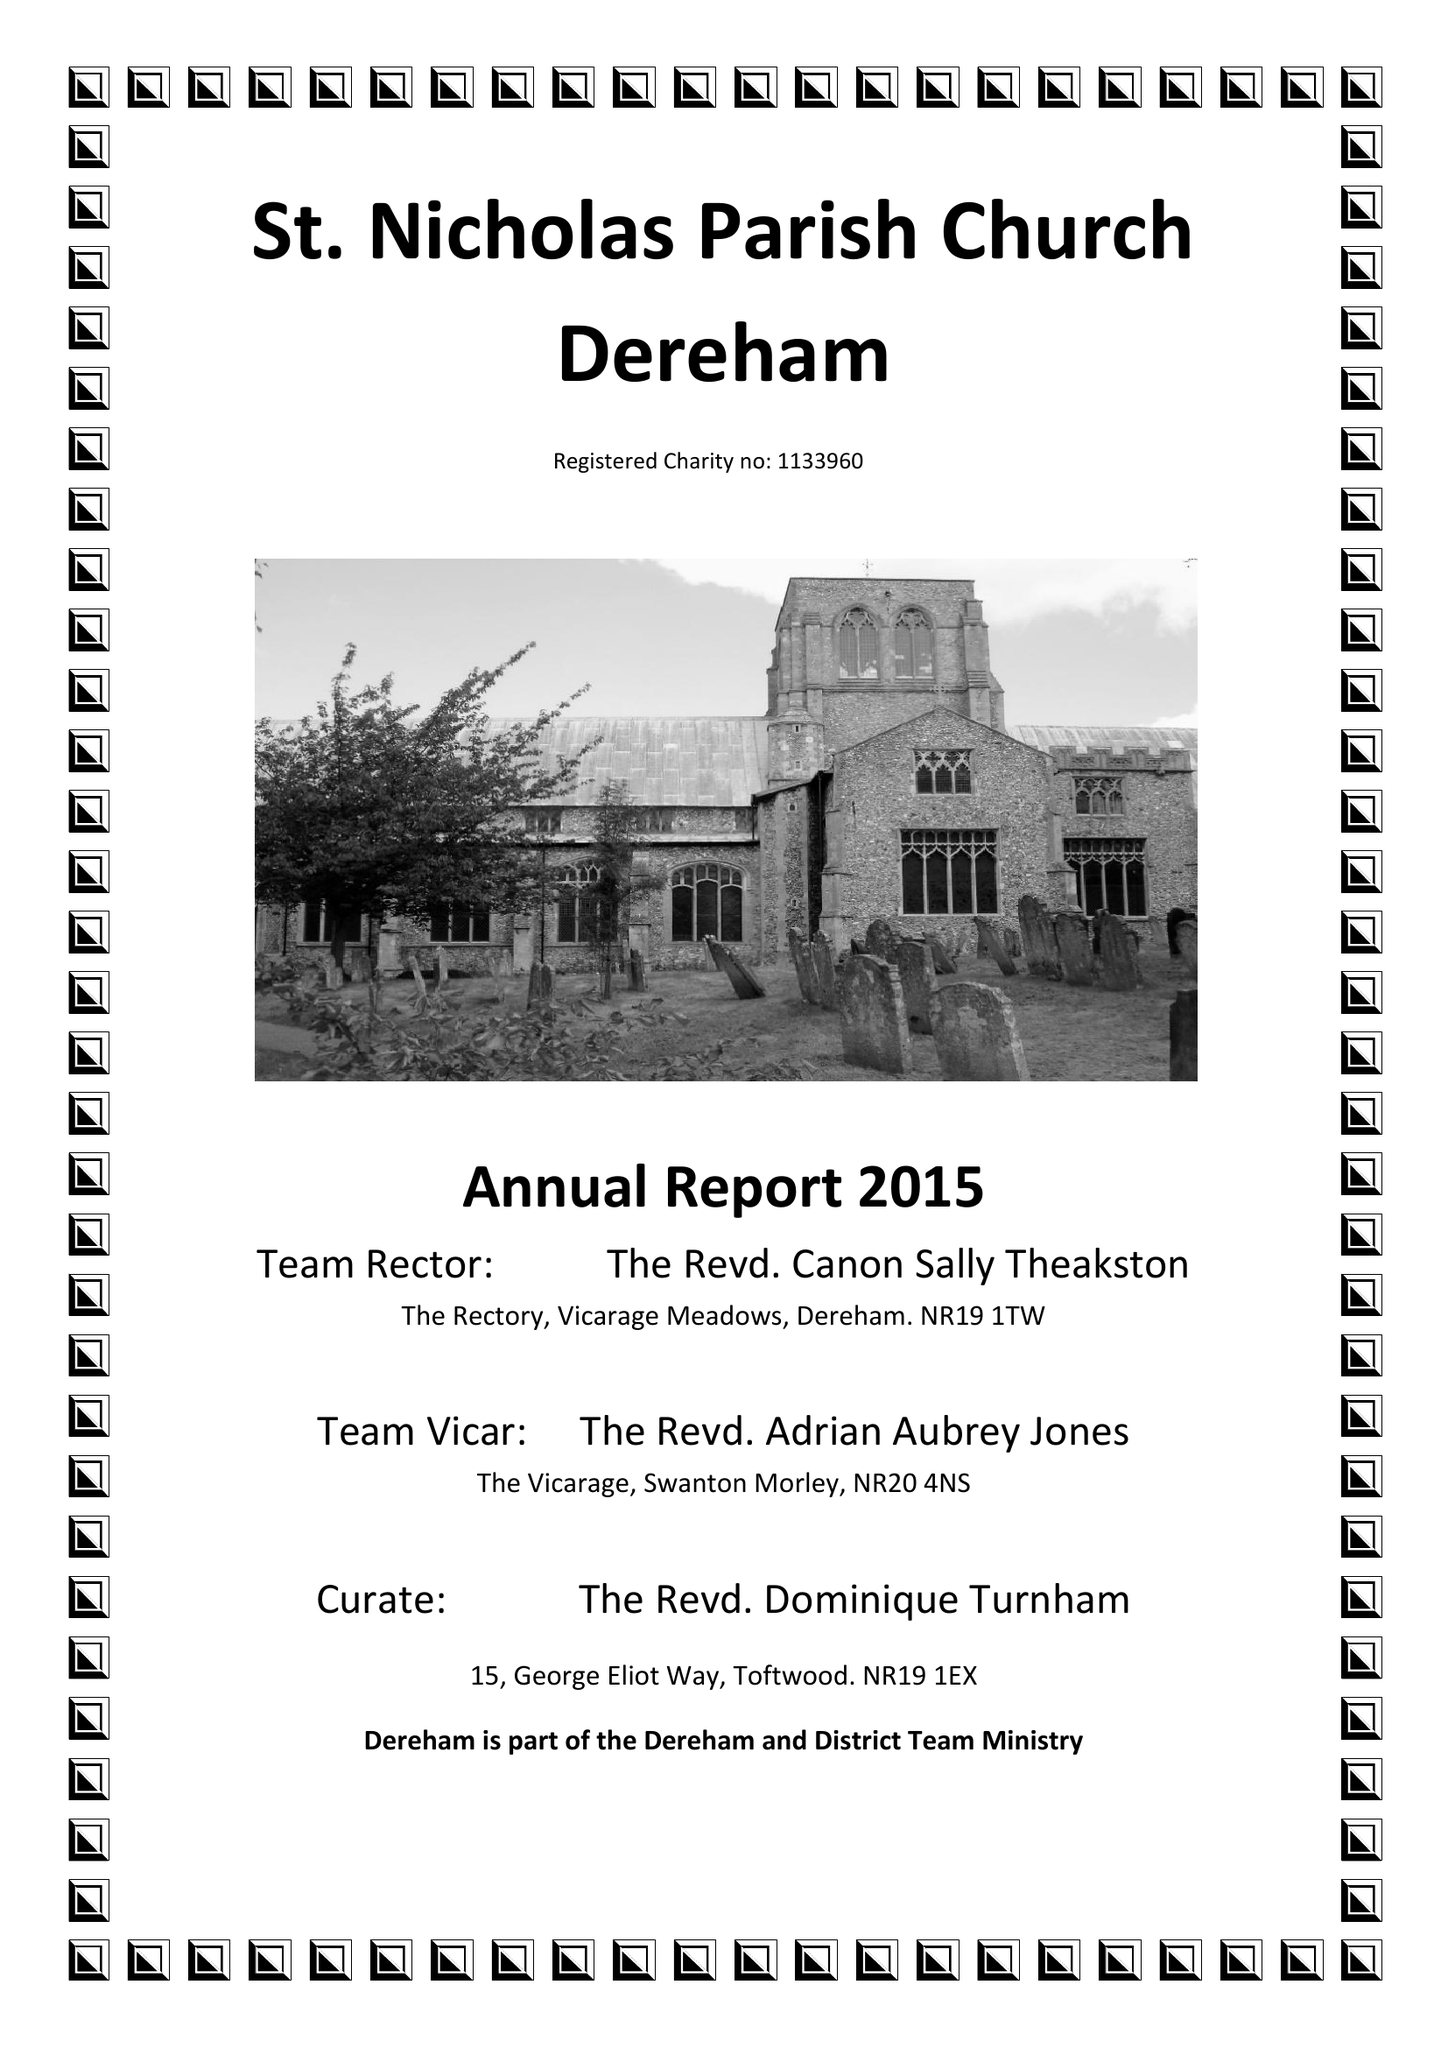What is the value for the address__post_town?
Answer the question using a single word or phrase. DEREHAM 